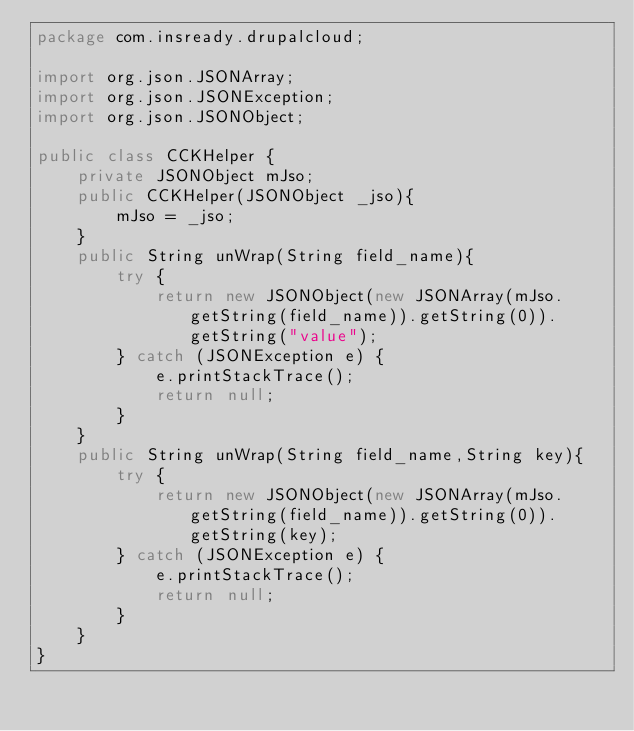Convert code to text. <code><loc_0><loc_0><loc_500><loc_500><_Java_>package com.insready.drupalcloud;

import org.json.JSONArray;
import org.json.JSONException;
import org.json.JSONObject;

public class CCKHelper {
	private JSONObject mJso;
	public CCKHelper(JSONObject _jso){
		mJso = _jso;
	}
	public String unWrap(String field_name){
		try {
			return new JSONObject(new JSONArray(mJso.getString(field_name)).getString(0)).getString("value");
		} catch (JSONException e) {
			e.printStackTrace();
			return null;
		}
	}
	public String unWrap(String field_name,String key){
		try {
			return new JSONObject(new JSONArray(mJso.getString(field_name)).getString(0)).getString(key);
		} catch (JSONException e) {
			e.printStackTrace();
			return null;
		}
	}
}
</code> 